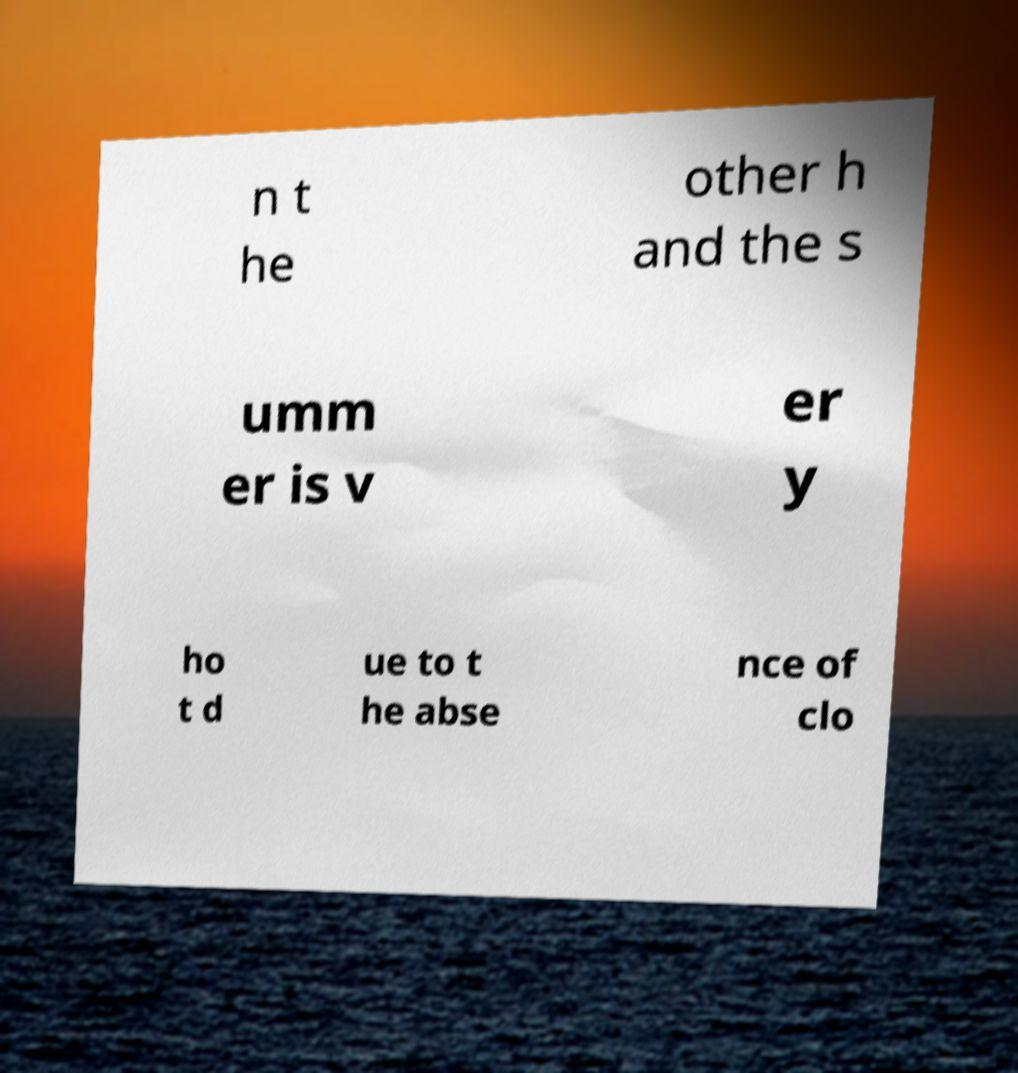What messages or text are displayed in this image? I need them in a readable, typed format. n t he other h and the s umm er is v er y ho t d ue to t he abse nce of clo 